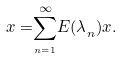Convert formula to latex. <formula><loc_0><loc_0><loc_500><loc_500>{ x = } \overset { \infty } { \underset { _ { n = 1 } } { \sum } } { E ( \lambda } _ { n } { ) x } .</formula> 